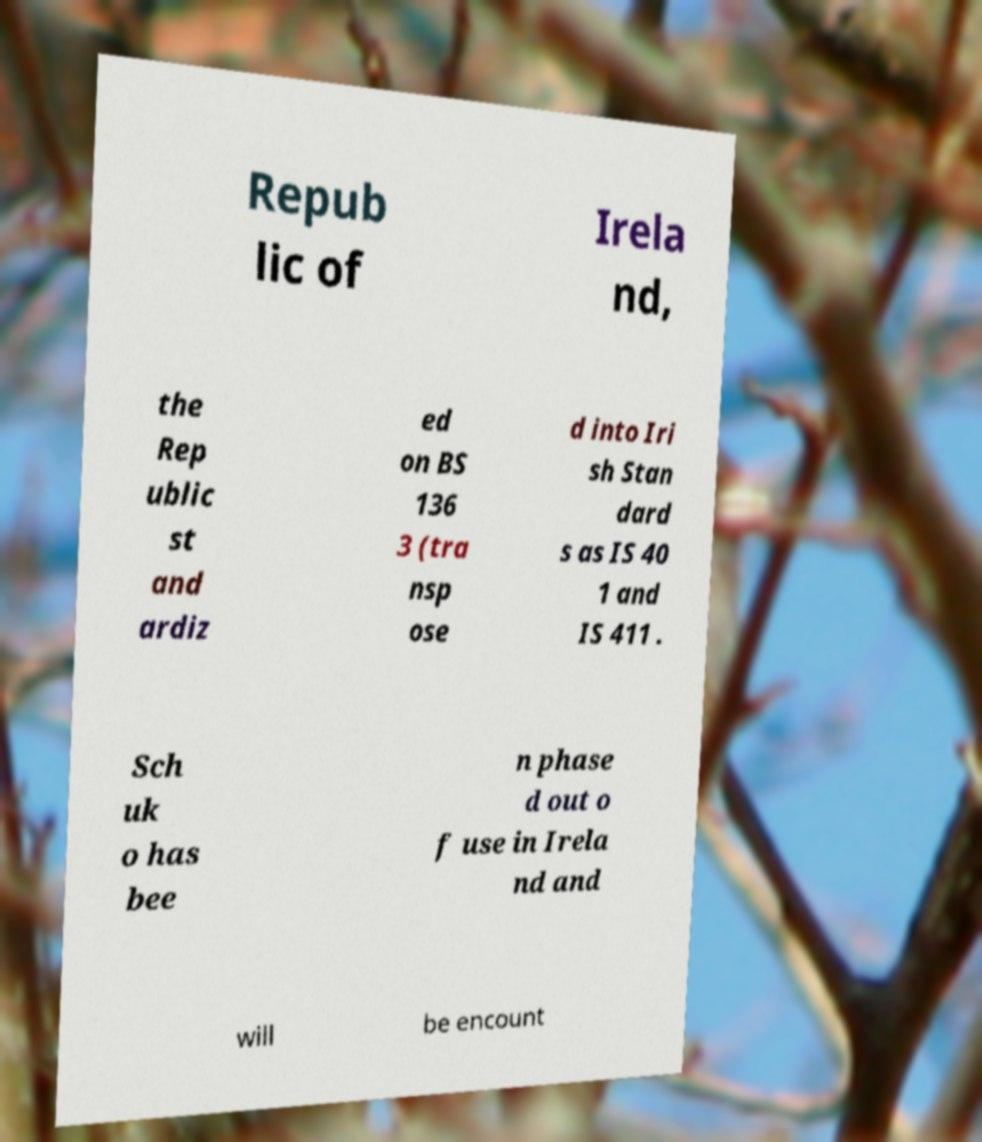For documentation purposes, I need the text within this image transcribed. Could you provide that? Repub lic of Irela nd, the Rep ublic st and ardiz ed on BS 136 3 (tra nsp ose d into Iri sh Stan dard s as IS 40 1 and IS 411 . Sch uk o has bee n phase d out o f use in Irela nd and will be encount 